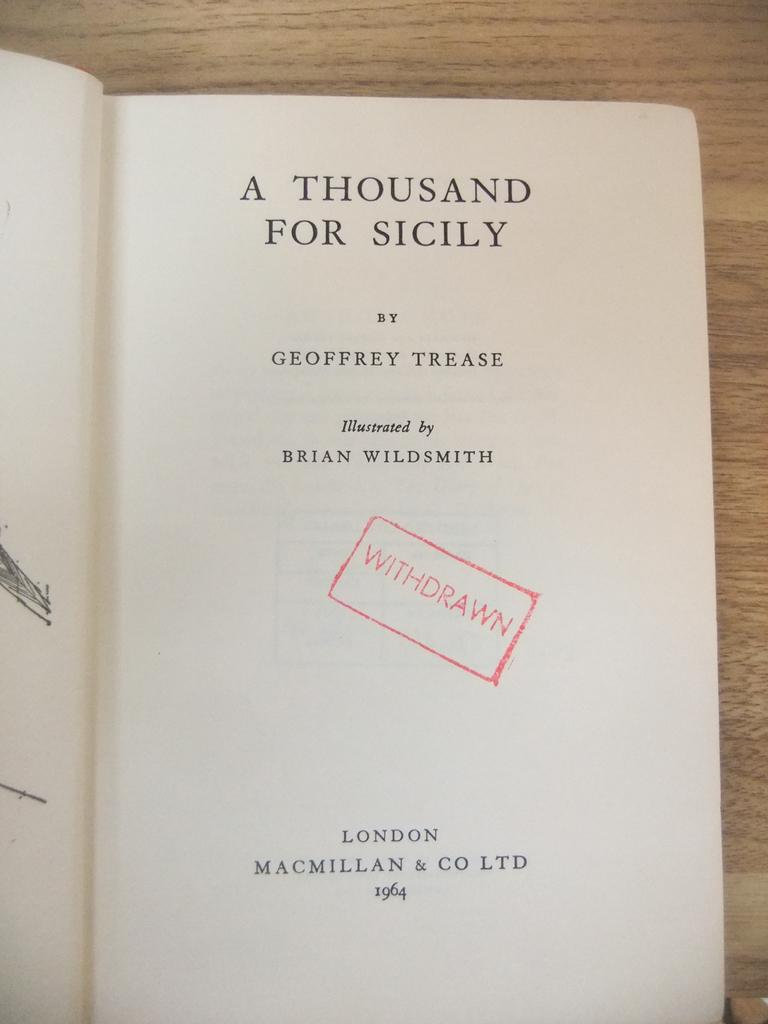Provide a one-sentence caption for the provided image. The title of a withdrawn libaray book titled A Thousand For Italy. 